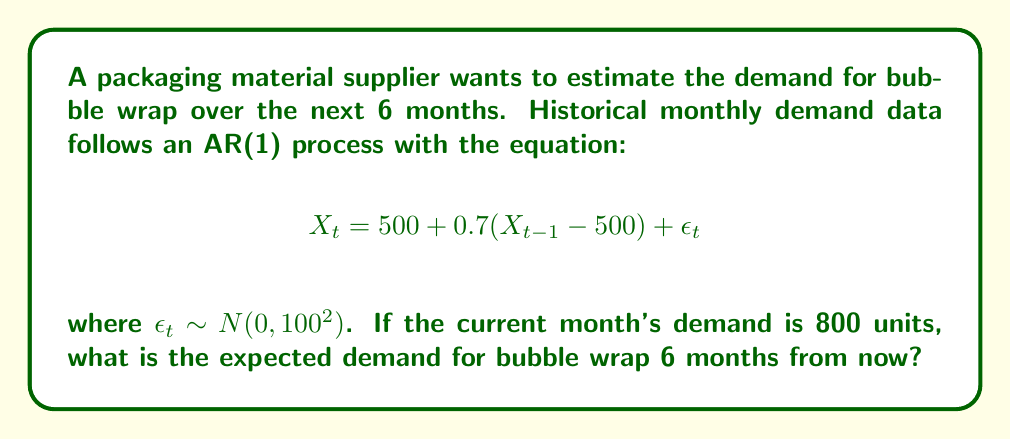What is the answer to this math problem? To solve this problem, we'll use the properties of the AR(1) process and its forecast equation:

1) The AR(1) process has a mean reversion property. The long-term mean (μ) is 500 units in this case.

2) The forecast equation for an AR(1) process k periods ahead is:

   $$E[X_{t+k}|X_t] = \mu + \phi^k(X_t - \mu)$$

   where φ is the AR coefficient (0.7 in this case).

3) We need to forecast 6 months ahead, so k = 6.

4) Plugging in the values:
   
   $$E[X_{t+6}|X_t] = 500 + 0.7^6(800 - 500)$$

5) Calculate 0.7^6:
   
   $$0.7^6 \approx 0.1176$$

6) Complete the calculation:
   
   $$E[X_{t+6}|X_t] = 500 + 0.1176(300) = 500 + 35.28 = 535.28$$

7) Round to the nearest whole unit as we're dealing with physical items.
Answer: 535 units 